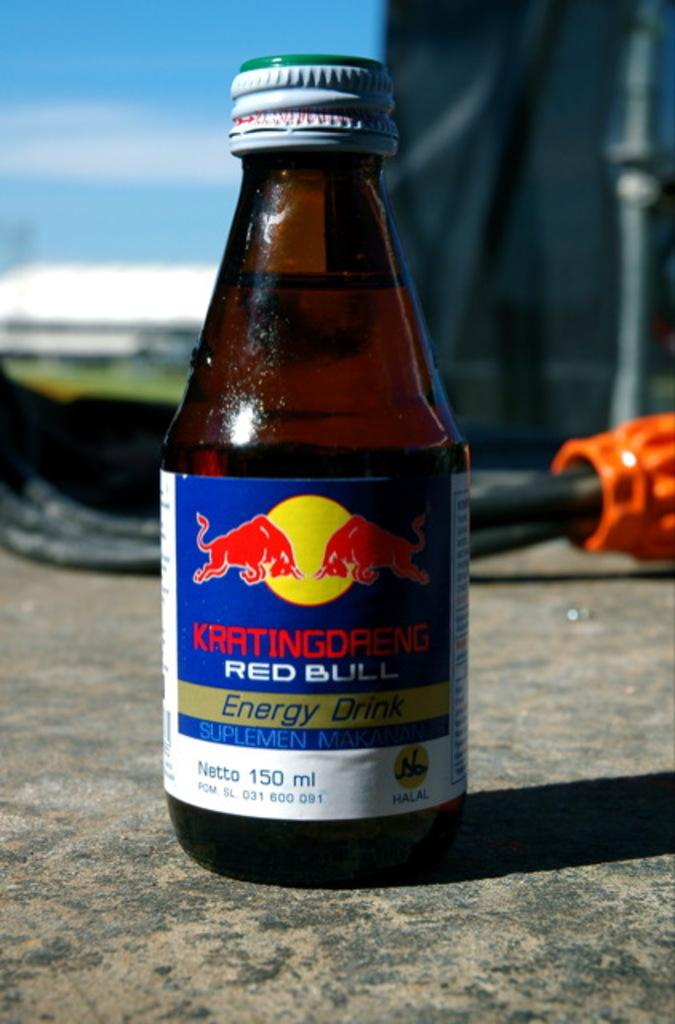<image>
Relay a brief, clear account of the picture shown. A rare glass bottle of the red bull energy drink 